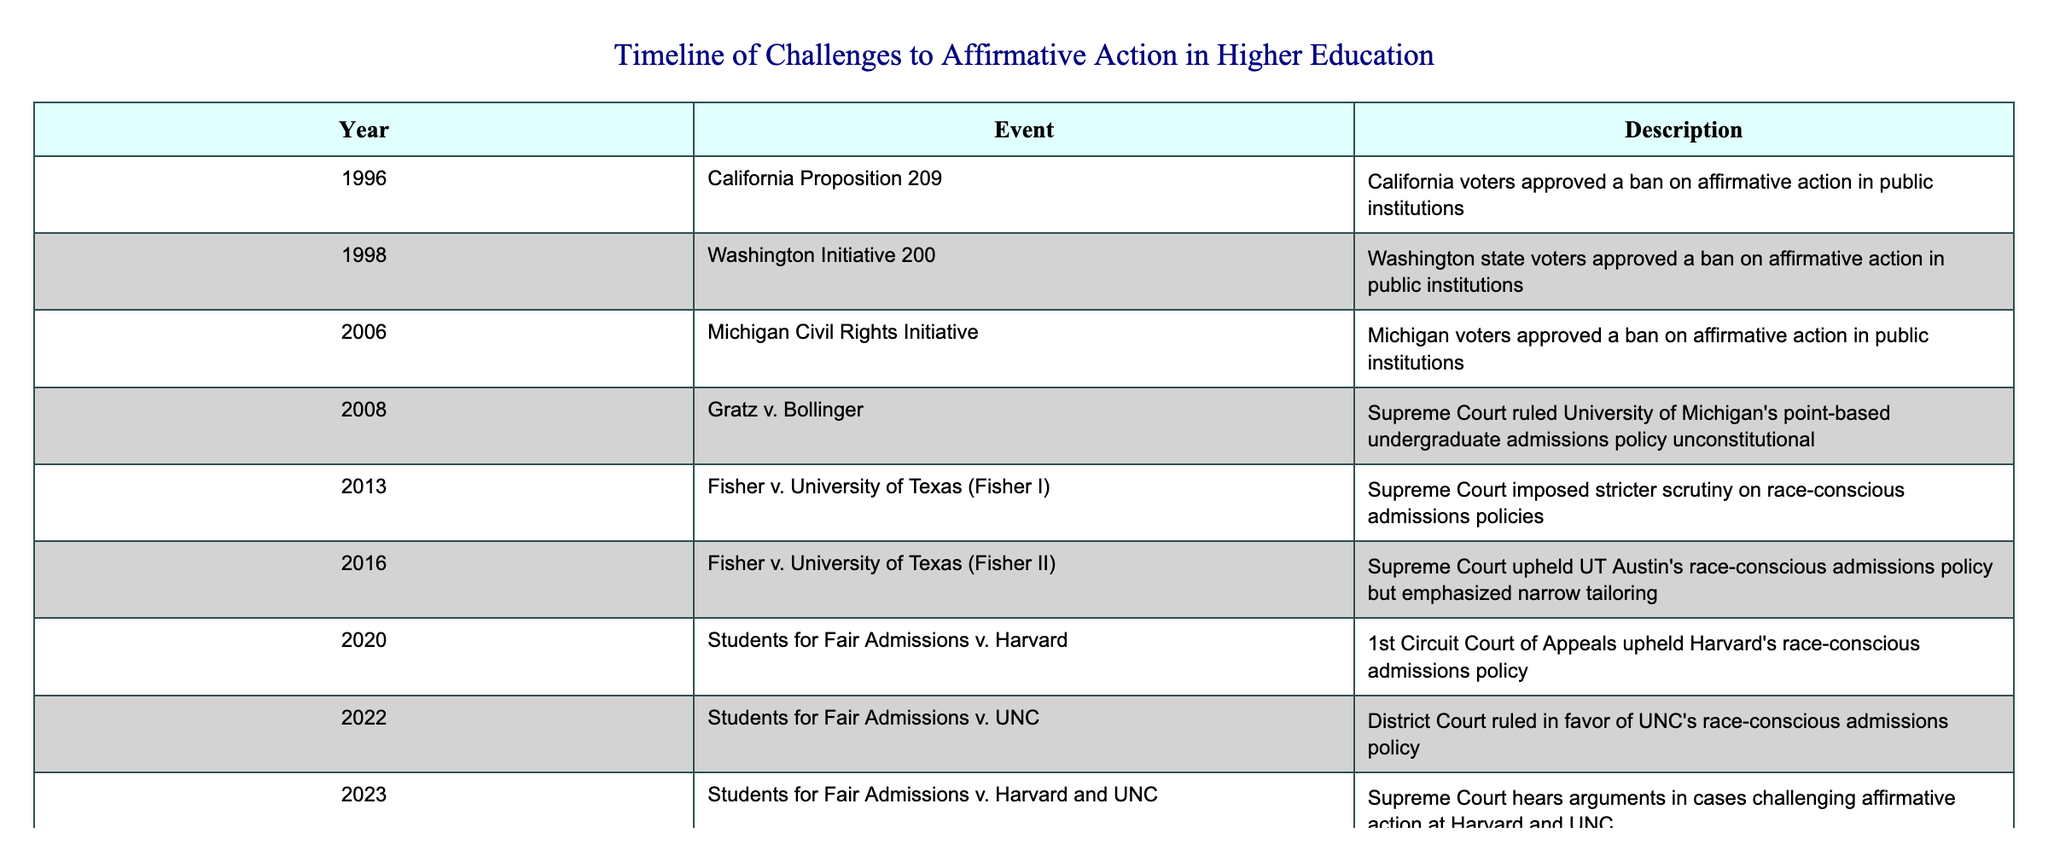What year did California pass Proposition 209? According to the table, California Proposition 209 was approved in 1996.
Answer: 1996 What is the description of the event that occurred in 2008? The event in 2008 was Gratz v. Bollinger, where the Supreme Court ruled the University of Michigan's point-based undergraduate admissions policy unconstitutional.
Answer: Supreme Court ruled University of Michigan's point-based undergraduate admissions policy unconstitutional Which event occurred first, Michigan Civil Rights Initiative or Fisher v. University of Texas (Fisher I)? The Michigan Civil Rights Initiative in 2006 occurred before Fisher v. University of Texas (Fisher I), which happened in 2013.
Answer: Michigan Civil Rights Initiative Was the Supreme Court's decision in Fisher v. University of Texas (Fisher II) in 2016 in favor of or against race-conscious admissions policies? The Supreme Court upheld the race-conscious admissions policy in Fisher v. University of Texas (Fisher II) but emphasized it had to be narrowly tailored, indicating a cautious approach rather than a complete endorsement.
Answer: In favor, with conditions How many events mentioned in the table occurred after 2010? There are 5 events that occurred after 2010: Fisher I (2013), Fisher II (2016), Students for Fair Admissions v. Harvard (2020), Students for Fair Admissions v. UNC (2022), and Students for Fair Admissions v. Harvard and UNC (2023).
Answer: 5 What is the total number of affirmative action challenges resolved by the Supreme Court according to the table? The Supreme Court resolved three challenges: Gratz v. Bollinger (2008), Fisher I (2013), and Fisher II (2016).
Answer: 3 Did any state pass a ban on affirmative action policies after 2006? Yes, Washington state passed a ban on affirmative action in 1998, and California's Proposition 209 also served as a model for later bans in other states.
Answer: Yes Which two regions (states) are involved in the cases heard by the Supreme Court in 2023? The cases challenging affirmative action in 2023 involved Harvard and the University of North Carolina (UNC).
Answer: Harvard and UNC What events exhibit a mix of both judicial and electoral challenges to affirmative action? The events California Proposition 209, Washington Initiative 200, and Michigan Civil Rights Initiative represent electoral challenges, while Gratz v. Bollinger and Fisher cases represent judicial challenges.
Answer: Both judicial and electoral challenges include the mentioned events 